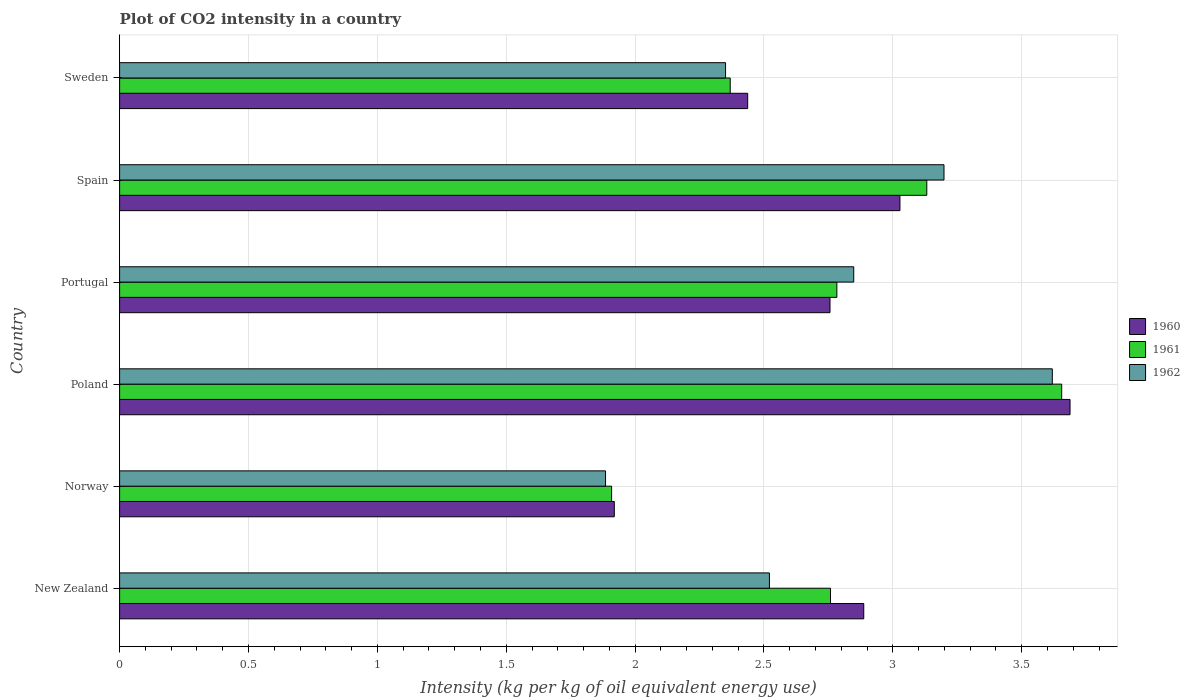How many different coloured bars are there?
Offer a terse response. 3. How many groups of bars are there?
Keep it short and to the point. 6. Are the number of bars per tick equal to the number of legend labels?
Keep it short and to the point. Yes. Are the number of bars on each tick of the Y-axis equal?
Provide a short and direct response. Yes. How many bars are there on the 3rd tick from the top?
Your response must be concise. 3. What is the label of the 1st group of bars from the top?
Give a very brief answer. Sweden. In how many cases, is the number of bars for a given country not equal to the number of legend labels?
Provide a succinct answer. 0. What is the CO2 intensity in in 1960 in Poland?
Ensure brevity in your answer.  3.69. Across all countries, what is the maximum CO2 intensity in in 1960?
Give a very brief answer. 3.69. Across all countries, what is the minimum CO2 intensity in in 1960?
Offer a terse response. 1.92. What is the total CO2 intensity in in 1960 in the graph?
Keep it short and to the point. 16.71. What is the difference between the CO2 intensity in in 1961 in Poland and that in Portugal?
Offer a terse response. 0.87. What is the difference between the CO2 intensity in in 1961 in Spain and the CO2 intensity in in 1960 in Sweden?
Offer a very short reply. 0.69. What is the average CO2 intensity in in 1962 per country?
Your answer should be compact. 2.74. What is the difference between the CO2 intensity in in 1960 and CO2 intensity in in 1962 in Spain?
Your response must be concise. -0.17. What is the ratio of the CO2 intensity in in 1960 in Norway to that in Spain?
Provide a succinct answer. 0.63. Is the CO2 intensity in in 1960 in Poland less than that in Portugal?
Ensure brevity in your answer.  No. What is the difference between the highest and the second highest CO2 intensity in in 1961?
Provide a succinct answer. 0.52. What is the difference between the highest and the lowest CO2 intensity in in 1962?
Your answer should be very brief. 1.73. What does the 2nd bar from the bottom in Portugal represents?
Give a very brief answer. 1961. Is it the case that in every country, the sum of the CO2 intensity in in 1960 and CO2 intensity in in 1961 is greater than the CO2 intensity in in 1962?
Ensure brevity in your answer.  Yes. How many bars are there?
Give a very brief answer. 18. Are all the bars in the graph horizontal?
Ensure brevity in your answer.  Yes. Are the values on the major ticks of X-axis written in scientific E-notation?
Provide a succinct answer. No. Does the graph contain any zero values?
Make the answer very short. No. Does the graph contain grids?
Offer a terse response. Yes. How many legend labels are there?
Offer a very short reply. 3. What is the title of the graph?
Your answer should be very brief. Plot of CO2 intensity in a country. Does "1996" appear as one of the legend labels in the graph?
Give a very brief answer. No. What is the label or title of the X-axis?
Ensure brevity in your answer.  Intensity (kg per kg of oil equivalent energy use). What is the label or title of the Y-axis?
Keep it short and to the point. Country. What is the Intensity (kg per kg of oil equivalent energy use) of 1960 in New Zealand?
Provide a short and direct response. 2.89. What is the Intensity (kg per kg of oil equivalent energy use) in 1961 in New Zealand?
Give a very brief answer. 2.76. What is the Intensity (kg per kg of oil equivalent energy use) in 1962 in New Zealand?
Give a very brief answer. 2.52. What is the Intensity (kg per kg of oil equivalent energy use) of 1960 in Norway?
Provide a succinct answer. 1.92. What is the Intensity (kg per kg of oil equivalent energy use) of 1961 in Norway?
Your answer should be very brief. 1.91. What is the Intensity (kg per kg of oil equivalent energy use) of 1962 in Norway?
Your answer should be very brief. 1.89. What is the Intensity (kg per kg of oil equivalent energy use) of 1960 in Poland?
Provide a succinct answer. 3.69. What is the Intensity (kg per kg of oil equivalent energy use) in 1961 in Poland?
Offer a very short reply. 3.66. What is the Intensity (kg per kg of oil equivalent energy use) of 1962 in Poland?
Your answer should be very brief. 3.62. What is the Intensity (kg per kg of oil equivalent energy use) of 1960 in Portugal?
Make the answer very short. 2.76. What is the Intensity (kg per kg of oil equivalent energy use) of 1961 in Portugal?
Give a very brief answer. 2.78. What is the Intensity (kg per kg of oil equivalent energy use) in 1962 in Portugal?
Offer a terse response. 2.85. What is the Intensity (kg per kg of oil equivalent energy use) of 1960 in Spain?
Make the answer very short. 3.03. What is the Intensity (kg per kg of oil equivalent energy use) in 1961 in Spain?
Ensure brevity in your answer.  3.13. What is the Intensity (kg per kg of oil equivalent energy use) of 1962 in Spain?
Provide a short and direct response. 3.2. What is the Intensity (kg per kg of oil equivalent energy use) in 1960 in Sweden?
Provide a short and direct response. 2.44. What is the Intensity (kg per kg of oil equivalent energy use) in 1961 in Sweden?
Your answer should be compact. 2.37. What is the Intensity (kg per kg of oil equivalent energy use) of 1962 in Sweden?
Your answer should be compact. 2.35. Across all countries, what is the maximum Intensity (kg per kg of oil equivalent energy use) in 1960?
Your response must be concise. 3.69. Across all countries, what is the maximum Intensity (kg per kg of oil equivalent energy use) of 1961?
Ensure brevity in your answer.  3.66. Across all countries, what is the maximum Intensity (kg per kg of oil equivalent energy use) in 1962?
Your answer should be compact. 3.62. Across all countries, what is the minimum Intensity (kg per kg of oil equivalent energy use) in 1960?
Your answer should be compact. 1.92. Across all countries, what is the minimum Intensity (kg per kg of oil equivalent energy use) of 1961?
Offer a very short reply. 1.91. Across all countries, what is the minimum Intensity (kg per kg of oil equivalent energy use) in 1962?
Make the answer very short. 1.89. What is the total Intensity (kg per kg of oil equivalent energy use) in 1960 in the graph?
Offer a terse response. 16.71. What is the total Intensity (kg per kg of oil equivalent energy use) in 1961 in the graph?
Ensure brevity in your answer.  16.61. What is the total Intensity (kg per kg of oil equivalent energy use) in 1962 in the graph?
Give a very brief answer. 16.42. What is the difference between the Intensity (kg per kg of oil equivalent energy use) in 1960 in New Zealand and that in Norway?
Make the answer very short. 0.97. What is the difference between the Intensity (kg per kg of oil equivalent energy use) in 1961 in New Zealand and that in Norway?
Offer a terse response. 0.85. What is the difference between the Intensity (kg per kg of oil equivalent energy use) of 1962 in New Zealand and that in Norway?
Give a very brief answer. 0.64. What is the difference between the Intensity (kg per kg of oil equivalent energy use) in 1960 in New Zealand and that in Poland?
Keep it short and to the point. -0.8. What is the difference between the Intensity (kg per kg of oil equivalent energy use) in 1961 in New Zealand and that in Poland?
Your answer should be very brief. -0.9. What is the difference between the Intensity (kg per kg of oil equivalent energy use) of 1962 in New Zealand and that in Poland?
Offer a terse response. -1.1. What is the difference between the Intensity (kg per kg of oil equivalent energy use) in 1960 in New Zealand and that in Portugal?
Provide a short and direct response. 0.13. What is the difference between the Intensity (kg per kg of oil equivalent energy use) in 1961 in New Zealand and that in Portugal?
Make the answer very short. -0.02. What is the difference between the Intensity (kg per kg of oil equivalent energy use) in 1962 in New Zealand and that in Portugal?
Your answer should be very brief. -0.33. What is the difference between the Intensity (kg per kg of oil equivalent energy use) of 1960 in New Zealand and that in Spain?
Your answer should be compact. -0.14. What is the difference between the Intensity (kg per kg of oil equivalent energy use) in 1961 in New Zealand and that in Spain?
Offer a very short reply. -0.37. What is the difference between the Intensity (kg per kg of oil equivalent energy use) in 1962 in New Zealand and that in Spain?
Your answer should be compact. -0.68. What is the difference between the Intensity (kg per kg of oil equivalent energy use) of 1960 in New Zealand and that in Sweden?
Make the answer very short. 0.45. What is the difference between the Intensity (kg per kg of oil equivalent energy use) of 1961 in New Zealand and that in Sweden?
Your answer should be compact. 0.39. What is the difference between the Intensity (kg per kg of oil equivalent energy use) of 1962 in New Zealand and that in Sweden?
Your answer should be compact. 0.17. What is the difference between the Intensity (kg per kg of oil equivalent energy use) of 1960 in Norway and that in Poland?
Offer a terse response. -1.77. What is the difference between the Intensity (kg per kg of oil equivalent energy use) of 1961 in Norway and that in Poland?
Your answer should be compact. -1.75. What is the difference between the Intensity (kg per kg of oil equivalent energy use) in 1962 in Norway and that in Poland?
Offer a terse response. -1.73. What is the difference between the Intensity (kg per kg of oil equivalent energy use) of 1960 in Norway and that in Portugal?
Your answer should be compact. -0.84. What is the difference between the Intensity (kg per kg of oil equivalent energy use) in 1961 in Norway and that in Portugal?
Offer a very short reply. -0.87. What is the difference between the Intensity (kg per kg of oil equivalent energy use) in 1962 in Norway and that in Portugal?
Your answer should be very brief. -0.96. What is the difference between the Intensity (kg per kg of oil equivalent energy use) of 1960 in Norway and that in Spain?
Provide a short and direct response. -1.11. What is the difference between the Intensity (kg per kg of oil equivalent energy use) of 1961 in Norway and that in Spain?
Your response must be concise. -1.22. What is the difference between the Intensity (kg per kg of oil equivalent energy use) of 1962 in Norway and that in Spain?
Ensure brevity in your answer.  -1.31. What is the difference between the Intensity (kg per kg of oil equivalent energy use) of 1960 in Norway and that in Sweden?
Your answer should be compact. -0.52. What is the difference between the Intensity (kg per kg of oil equivalent energy use) in 1961 in Norway and that in Sweden?
Provide a succinct answer. -0.46. What is the difference between the Intensity (kg per kg of oil equivalent energy use) in 1962 in Norway and that in Sweden?
Your answer should be very brief. -0.47. What is the difference between the Intensity (kg per kg of oil equivalent energy use) in 1960 in Poland and that in Portugal?
Offer a terse response. 0.93. What is the difference between the Intensity (kg per kg of oil equivalent energy use) in 1961 in Poland and that in Portugal?
Provide a succinct answer. 0.87. What is the difference between the Intensity (kg per kg of oil equivalent energy use) of 1962 in Poland and that in Portugal?
Give a very brief answer. 0.77. What is the difference between the Intensity (kg per kg of oil equivalent energy use) in 1960 in Poland and that in Spain?
Your answer should be compact. 0.66. What is the difference between the Intensity (kg per kg of oil equivalent energy use) of 1961 in Poland and that in Spain?
Keep it short and to the point. 0.52. What is the difference between the Intensity (kg per kg of oil equivalent energy use) of 1962 in Poland and that in Spain?
Offer a very short reply. 0.42. What is the difference between the Intensity (kg per kg of oil equivalent energy use) of 1960 in Poland and that in Sweden?
Offer a very short reply. 1.25. What is the difference between the Intensity (kg per kg of oil equivalent energy use) in 1961 in Poland and that in Sweden?
Provide a short and direct response. 1.29. What is the difference between the Intensity (kg per kg of oil equivalent energy use) in 1962 in Poland and that in Sweden?
Your response must be concise. 1.27. What is the difference between the Intensity (kg per kg of oil equivalent energy use) of 1960 in Portugal and that in Spain?
Ensure brevity in your answer.  -0.27. What is the difference between the Intensity (kg per kg of oil equivalent energy use) in 1961 in Portugal and that in Spain?
Your answer should be compact. -0.35. What is the difference between the Intensity (kg per kg of oil equivalent energy use) in 1962 in Portugal and that in Spain?
Offer a terse response. -0.35. What is the difference between the Intensity (kg per kg of oil equivalent energy use) of 1960 in Portugal and that in Sweden?
Offer a very short reply. 0.32. What is the difference between the Intensity (kg per kg of oil equivalent energy use) of 1961 in Portugal and that in Sweden?
Make the answer very short. 0.41. What is the difference between the Intensity (kg per kg of oil equivalent energy use) of 1962 in Portugal and that in Sweden?
Provide a succinct answer. 0.5. What is the difference between the Intensity (kg per kg of oil equivalent energy use) in 1960 in Spain and that in Sweden?
Provide a short and direct response. 0.59. What is the difference between the Intensity (kg per kg of oil equivalent energy use) in 1961 in Spain and that in Sweden?
Your answer should be very brief. 0.76. What is the difference between the Intensity (kg per kg of oil equivalent energy use) of 1962 in Spain and that in Sweden?
Give a very brief answer. 0.85. What is the difference between the Intensity (kg per kg of oil equivalent energy use) in 1960 in New Zealand and the Intensity (kg per kg of oil equivalent energy use) in 1961 in Norway?
Give a very brief answer. 0.98. What is the difference between the Intensity (kg per kg of oil equivalent energy use) in 1961 in New Zealand and the Intensity (kg per kg of oil equivalent energy use) in 1962 in Norway?
Your answer should be compact. 0.87. What is the difference between the Intensity (kg per kg of oil equivalent energy use) of 1960 in New Zealand and the Intensity (kg per kg of oil equivalent energy use) of 1961 in Poland?
Your answer should be very brief. -0.77. What is the difference between the Intensity (kg per kg of oil equivalent energy use) of 1960 in New Zealand and the Intensity (kg per kg of oil equivalent energy use) of 1962 in Poland?
Offer a terse response. -0.73. What is the difference between the Intensity (kg per kg of oil equivalent energy use) in 1961 in New Zealand and the Intensity (kg per kg of oil equivalent energy use) in 1962 in Poland?
Your answer should be compact. -0.86. What is the difference between the Intensity (kg per kg of oil equivalent energy use) of 1960 in New Zealand and the Intensity (kg per kg of oil equivalent energy use) of 1961 in Portugal?
Give a very brief answer. 0.1. What is the difference between the Intensity (kg per kg of oil equivalent energy use) in 1960 in New Zealand and the Intensity (kg per kg of oil equivalent energy use) in 1962 in Portugal?
Give a very brief answer. 0.04. What is the difference between the Intensity (kg per kg of oil equivalent energy use) of 1961 in New Zealand and the Intensity (kg per kg of oil equivalent energy use) of 1962 in Portugal?
Offer a terse response. -0.09. What is the difference between the Intensity (kg per kg of oil equivalent energy use) of 1960 in New Zealand and the Intensity (kg per kg of oil equivalent energy use) of 1961 in Spain?
Keep it short and to the point. -0.24. What is the difference between the Intensity (kg per kg of oil equivalent energy use) of 1960 in New Zealand and the Intensity (kg per kg of oil equivalent energy use) of 1962 in Spain?
Ensure brevity in your answer.  -0.31. What is the difference between the Intensity (kg per kg of oil equivalent energy use) of 1961 in New Zealand and the Intensity (kg per kg of oil equivalent energy use) of 1962 in Spain?
Provide a succinct answer. -0.44. What is the difference between the Intensity (kg per kg of oil equivalent energy use) of 1960 in New Zealand and the Intensity (kg per kg of oil equivalent energy use) of 1961 in Sweden?
Your answer should be very brief. 0.52. What is the difference between the Intensity (kg per kg of oil equivalent energy use) of 1960 in New Zealand and the Intensity (kg per kg of oil equivalent energy use) of 1962 in Sweden?
Keep it short and to the point. 0.54. What is the difference between the Intensity (kg per kg of oil equivalent energy use) of 1961 in New Zealand and the Intensity (kg per kg of oil equivalent energy use) of 1962 in Sweden?
Keep it short and to the point. 0.41. What is the difference between the Intensity (kg per kg of oil equivalent energy use) in 1960 in Norway and the Intensity (kg per kg of oil equivalent energy use) in 1961 in Poland?
Provide a short and direct response. -1.74. What is the difference between the Intensity (kg per kg of oil equivalent energy use) in 1960 in Norway and the Intensity (kg per kg of oil equivalent energy use) in 1962 in Poland?
Your answer should be very brief. -1.7. What is the difference between the Intensity (kg per kg of oil equivalent energy use) in 1961 in Norway and the Intensity (kg per kg of oil equivalent energy use) in 1962 in Poland?
Offer a terse response. -1.71. What is the difference between the Intensity (kg per kg of oil equivalent energy use) of 1960 in Norway and the Intensity (kg per kg of oil equivalent energy use) of 1961 in Portugal?
Keep it short and to the point. -0.86. What is the difference between the Intensity (kg per kg of oil equivalent energy use) in 1960 in Norway and the Intensity (kg per kg of oil equivalent energy use) in 1962 in Portugal?
Your answer should be compact. -0.93. What is the difference between the Intensity (kg per kg of oil equivalent energy use) in 1961 in Norway and the Intensity (kg per kg of oil equivalent energy use) in 1962 in Portugal?
Provide a short and direct response. -0.94. What is the difference between the Intensity (kg per kg of oil equivalent energy use) of 1960 in Norway and the Intensity (kg per kg of oil equivalent energy use) of 1961 in Spain?
Provide a succinct answer. -1.21. What is the difference between the Intensity (kg per kg of oil equivalent energy use) of 1960 in Norway and the Intensity (kg per kg of oil equivalent energy use) of 1962 in Spain?
Your answer should be very brief. -1.28. What is the difference between the Intensity (kg per kg of oil equivalent energy use) in 1961 in Norway and the Intensity (kg per kg of oil equivalent energy use) in 1962 in Spain?
Offer a terse response. -1.29. What is the difference between the Intensity (kg per kg of oil equivalent energy use) in 1960 in Norway and the Intensity (kg per kg of oil equivalent energy use) in 1961 in Sweden?
Your answer should be very brief. -0.45. What is the difference between the Intensity (kg per kg of oil equivalent energy use) of 1960 in Norway and the Intensity (kg per kg of oil equivalent energy use) of 1962 in Sweden?
Make the answer very short. -0.43. What is the difference between the Intensity (kg per kg of oil equivalent energy use) in 1961 in Norway and the Intensity (kg per kg of oil equivalent energy use) in 1962 in Sweden?
Ensure brevity in your answer.  -0.44. What is the difference between the Intensity (kg per kg of oil equivalent energy use) of 1960 in Poland and the Intensity (kg per kg of oil equivalent energy use) of 1961 in Portugal?
Your answer should be compact. 0.9. What is the difference between the Intensity (kg per kg of oil equivalent energy use) of 1960 in Poland and the Intensity (kg per kg of oil equivalent energy use) of 1962 in Portugal?
Ensure brevity in your answer.  0.84. What is the difference between the Intensity (kg per kg of oil equivalent energy use) of 1961 in Poland and the Intensity (kg per kg of oil equivalent energy use) of 1962 in Portugal?
Provide a short and direct response. 0.81. What is the difference between the Intensity (kg per kg of oil equivalent energy use) in 1960 in Poland and the Intensity (kg per kg of oil equivalent energy use) in 1961 in Spain?
Your answer should be compact. 0.56. What is the difference between the Intensity (kg per kg of oil equivalent energy use) in 1960 in Poland and the Intensity (kg per kg of oil equivalent energy use) in 1962 in Spain?
Your response must be concise. 0.49. What is the difference between the Intensity (kg per kg of oil equivalent energy use) in 1961 in Poland and the Intensity (kg per kg of oil equivalent energy use) in 1962 in Spain?
Offer a terse response. 0.46. What is the difference between the Intensity (kg per kg of oil equivalent energy use) of 1960 in Poland and the Intensity (kg per kg of oil equivalent energy use) of 1961 in Sweden?
Give a very brief answer. 1.32. What is the difference between the Intensity (kg per kg of oil equivalent energy use) of 1960 in Poland and the Intensity (kg per kg of oil equivalent energy use) of 1962 in Sweden?
Give a very brief answer. 1.34. What is the difference between the Intensity (kg per kg of oil equivalent energy use) in 1961 in Poland and the Intensity (kg per kg of oil equivalent energy use) in 1962 in Sweden?
Ensure brevity in your answer.  1.3. What is the difference between the Intensity (kg per kg of oil equivalent energy use) of 1960 in Portugal and the Intensity (kg per kg of oil equivalent energy use) of 1961 in Spain?
Ensure brevity in your answer.  -0.38. What is the difference between the Intensity (kg per kg of oil equivalent energy use) in 1960 in Portugal and the Intensity (kg per kg of oil equivalent energy use) in 1962 in Spain?
Keep it short and to the point. -0.44. What is the difference between the Intensity (kg per kg of oil equivalent energy use) of 1961 in Portugal and the Intensity (kg per kg of oil equivalent energy use) of 1962 in Spain?
Make the answer very short. -0.42. What is the difference between the Intensity (kg per kg of oil equivalent energy use) of 1960 in Portugal and the Intensity (kg per kg of oil equivalent energy use) of 1961 in Sweden?
Provide a succinct answer. 0.39. What is the difference between the Intensity (kg per kg of oil equivalent energy use) of 1960 in Portugal and the Intensity (kg per kg of oil equivalent energy use) of 1962 in Sweden?
Your answer should be very brief. 0.41. What is the difference between the Intensity (kg per kg of oil equivalent energy use) of 1961 in Portugal and the Intensity (kg per kg of oil equivalent energy use) of 1962 in Sweden?
Provide a succinct answer. 0.43. What is the difference between the Intensity (kg per kg of oil equivalent energy use) of 1960 in Spain and the Intensity (kg per kg of oil equivalent energy use) of 1961 in Sweden?
Make the answer very short. 0.66. What is the difference between the Intensity (kg per kg of oil equivalent energy use) in 1960 in Spain and the Intensity (kg per kg of oil equivalent energy use) in 1962 in Sweden?
Your response must be concise. 0.68. What is the difference between the Intensity (kg per kg of oil equivalent energy use) in 1961 in Spain and the Intensity (kg per kg of oil equivalent energy use) in 1962 in Sweden?
Keep it short and to the point. 0.78. What is the average Intensity (kg per kg of oil equivalent energy use) of 1960 per country?
Your answer should be compact. 2.79. What is the average Intensity (kg per kg of oil equivalent energy use) in 1961 per country?
Keep it short and to the point. 2.77. What is the average Intensity (kg per kg of oil equivalent energy use) in 1962 per country?
Your answer should be compact. 2.74. What is the difference between the Intensity (kg per kg of oil equivalent energy use) in 1960 and Intensity (kg per kg of oil equivalent energy use) in 1961 in New Zealand?
Ensure brevity in your answer.  0.13. What is the difference between the Intensity (kg per kg of oil equivalent energy use) in 1960 and Intensity (kg per kg of oil equivalent energy use) in 1962 in New Zealand?
Make the answer very short. 0.37. What is the difference between the Intensity (kg per kg of oil equivalent energy use) of 1961 and Intensity (kg per kg of oil equivalent energy use) of 1962 in New Zealand?
Your response must be concise. 0.24. What is the difference between the Intensity (kg per kg of oil equivalent energy use) in 1960 and Intensity (kg per kg of oil equivalent energy use) in 1961 in Norway?
Make the answer very short. 0.01. What is the difference between the Intensity (kg per kg of oil equivalent energy use) in 1960 and Intensity (kg per kg of oil equivalent energy use) in 1962 in Norway?
Your response must be concise. 0.03. What is the difference between the Intensity (kg per kg of oil equivalent energy use) of 1961 and Intensity (kg per kg of oil equivalent energy use) of 1962 in Norway?
Your response must be concise. 0.02. What is the difference between the Intensity (kg per kg of oil equivalent energy use) in 1960 and Intensity (kg per kg of oil equivalent energy use) in 1961 in Poland?
Give a very brief answer. 0.03. What is the difference between the Intensity (kg per kg of oil equivalent energy use) in 1960 and Intensity (kg per kg of oil equivalent energy use) in 1962 in Poland?
Ensure brevity in your answer.  0.07. What is the difference between the Intensity (kg per kg of oil equivalent energy use) of 1961 and Intensity (kg per kg of oil equivalent energy use) of 1962 in Poland?
Offer a very short reply. 0.04. What is the difference between the Intensity (kg per kg of oil equivalent energy use) in 1960 and Intensity (kg per kg of oil equivalent energy use) in 1961 in Portugal?
Your response must be concise. -0.03. What is the difference between the Intensity (kg per kg of oil equivalent energy use) in 1960 and Intensity (kg per kg of oil equivalent energy use) in 1962 in Portugal?
Make the answer very short. -0.09. What is the difference between the Intensity (kg per kg of oil equivalent energy use) in 1961 and Intensity (kg per kg of oil equivalent energy use) in 1962 in Portugal?
Your response must be concise. -0.07. What is the difference between the Intensity (kg per kg of oil equivalent energy use) in 1960 and Intensity (kg per kg of oil equivalent energy use) in 1961 in Spain?
Ensure brevity in your answer.  -0.1. What is the difference between the Intensity (kg per kg of oil equivalent energy use) in 1960 and Intensity (kg per kg of oil equivalent energy use) in 1962 in Spain?
Your response must be concise. -0.17. What is the difference between the Intensity (kg per kg of oil equivalent energy use) of 1961 and Intensity (kg per kg of oil equivalent energy use) of 1962 in Spain?
Provide a short and direct response. -0.07. What is the difference between the Intensity (kg per kg of oil equivalent energy use) in 1960 and Intensity (kg per kg of oil equivalent energy use) in 1961 in Sweden?
Provide a short and direct response. 0.07. What is the difference between the Intensity (kg per kg of oil equivalent energy use) in 1960 and Intensity (kg per kg of oil equivalent energy use) in 1962 in Sweden?
Offer a terse response. 0.09. What is the difference between the Intensity (kg per kg of oil equivalent energy use) of 1961 and Intensity (kg per kg of oil equivalent energy use) of 1962 in Sweden?
Ensure brevity in your answer.  0.02. What is the ratio of the Intensity (kg per kg of oil equivalent energy use) in 1960 in New Zealand to that in Norway?
Your answer should be very brief. 1.5. What is the ratio of the Intensity (kg per kg of oil equivalent energy use) in 1961 in New Zealand to that in Norway?
Your response must be concise. 1.44. What is the ratio of the Intensity (kg per kg of oil equivalent energy use) in 1962 in New Zealand to that in Norway?
Give a very brief answer. 1.34. What is the ratio of the Intensity (kg per kg of oil equivalent energy use) of 1960 in New Zealand to that in Poland?
Your answer should be compact. 0.78. What is the ratio of the Intensity (kg per kg of oil equivalent energy use) in 1961 in New Zealand to that in Poland?
Make the answer very short. 0.75. What is the ratio of the Intensity (kg per kg of oil equivalent energy use) of 1962 in New Zealand to that in Poland?
Provide a succinct answer. 0.7. What is the ratio of the Intensity (kg per kg of oil equivalent energy use) in 1960 in New Zealand to that in Portugal?
Give a very brief answer. 1.05. What is the ratio of the Intensity (kg per kg of oil equivalent energy use) in 1962 in New Zealand to that in Portugal?
Keep it short and to the point. 0.89. What is the ratio of the Intensity (kg per kg of oil equivalent energy use) of 1960 in New Zealand to that in Spain?
Your response must be concise. 0.95. What is the ratio of the Intensity (kg per kg of oil equivalent energy use) in 1961 in New Zealand to that in Spain?
Your answer should be very brief. 0.88. What is the ratio of the Intensity (kg per kg of oil equivalent energy use) of 1962 in New Zealand to that in Spain?
Give a very brief answer. 0.79. What is the ratio of the Intensity (kg per kg of oil equivalent energy use) in 1960 in New Zealand to that in Sweden?
Your answer should be compact. 1.18. What is the ratio of the Intensity (kg per kg of oil equivalent energy use) of 1961 in New Zealand to that in Sweden?
Keep it short and to the point. 1.16. What is the ratio of the Intensity (kg per kg of oil equivalent energy use) of 1962 in New Zealand to that in Sweden?
Keep it short and to the point. 1.07. What is the ratio of the Intensity (kg per kg of oil equivalent energy use) of 1960 in Norway to that in Poland?
Make the answer very short. 0.52. What is the ratio of the Intensity (kg per kg of oil equivalent energy use) of 1961 in Norway to that in Poland?
Your answer should be compact. 0.52. What is the ratio of the Intensity (kg per kg of oil equivalent energy use) of 1962 in Norway to that in Poland?
Provide a short and direct response. 0.52. What is the ratio of the Intensity (kg per kg of oil equivalent energy use) of 1960 in Norway to that in Portugal?
Ensure brevity in your answer.  0.7. What is the ratio of the Intensity (kg per kg of oil equivalent energy use) in 1961 in Norway to that in Portugal?
Provide a succinct answer. 0.69. What is the ratio of the Intensity (kg per kg of oil equivalent energy use) of 1962 in Norway to that in Portugal?
Offer a terse response. 0.66. What is the ratio of the Intensity (kg per kg of oil equivalent energy use) of 1960 in Norway to that in Spain?
Make the answer very short. 0.63. What is the ratio of the Intensity (kg per kg of oil equivalent energy use) of 1961 in Norway to that in Spain?
Offer a terse response. 0.61. What is the ratio of the Intensity (kg per kg of oil equivalent energy use) of 1962 in Norway to that in Spain?
Offer a terse response. 0.59. What is the ratio of the Intensity (kg per kg of oil equivalent energy use) of 1960 in Norway to that in Sweden?
Keep it short and to the point. 0.79. What is the ratio of the Intensity (kg per kg of oil equivalent energy use) of 1961 in Norway to that in Sweden?
Provide a short and direct response. 0.81. What is the ratio of the Intensity (kg per kg of oil equivalent energy use) of 1962 in Norway to that in Sweden?
Your answer should be very brief. 0.8. What is the ratio of the Intensity (kg per kg of oil equivalent energy use) in 1960 in Poland to that in Portugal?
Offer a very short reply. 1.34. What is the ratio of the Intensity (kg per kg of oil equivalent energy use) of 1961 in Poland to that in Portugal?
Offer a very short reply. 1.31. What is the ratio of the Intensity (kg per kg of oil equivalent energy use) of 1962 in Poland to that in Portugal?
Your response must be concise. 1.27. What is the ratio of the Intensity (kg per kg of oil equivalent energy use) of 1960 in Poland to that in Spain?
Provide a short and direct response. 1.22. What is the ratio of the Intensity (kg per kg of oil equivalent energy use) in 1961 in Poland to that in Spain?
Your response must be concise. 1.17. What is the ratio of the Intensity (kg per kg of oil equivalent energy use) in 1962 in Poland to that in Spain?
Your response must be concise. 1.13. What is the ratio of the Intensity (kg per kg of oil equivalent energy use) in 1960 in Poland to that in Sweden?
Your response must be concise. 1.51. What is the ratio of the Intensity (kg per kg of oil equivalent energy use) of 1961 in Poland to that in Sweden?
Your answer should be very brief. 1.54. What is the ratio of the Intensity (kg per kg of oil equivalent energy use) of 1962 in Poland to that in Sweden?
Provide a short and direct response. 1.54. What is the ratio of the Intensity (kg per kg of oil equivalent energy use) in 1960 in Portugal to that in Spain?
Offer a terse response. 0.91. What is the ratio of the Intensity (kg per kg of oil equivalent energy use) of 1961 in Portugal to that in Spain?
Ensure brevity in your answer.  0.89. What is the ratio of the Intensity (kg per kg of oil equivalent energy use) in 1962 in Portugal to that in Spain?
Offer a terse response. 0.89. What is the ratio of the Intensity (kg per kg of oil equivalent energy use) of 1960 in Portugal to that in Sweden?
Your answer should be compact. 1.13. What is the ratio of the Intensity (kg per kg of oil equivalent energy use) of 1961 in Portugal to that in Sweden?
Your answer should be compact. 1.17. What is the ratio of the Intensity (kg per kg of oil equivalent energy use) of 1962 in Portugal to that in Sweden?
Ensure brevity in your answer.  1.21. What is the ratio of the Intensity (kg per kg of oil equivalent energy use) of 1960 in Spain to that in Sweden?
Provide a short and direct response. 1.24. What is the ratio of the Intensity (kg per kg of oil equivalent energy use) of 1961 in Spain to that in Sweden?
Provide a short and direct response. 1.32. What is the ratio of the Intensity (kg per kg of oil equivalent energy use) in 1962 in Spain to that in Sweden?
Provide a short and direct response. 1.36. What is the difference between the highest and the second highest Intensity (kg per kg of oil equivalent energy use) of 1960?
Your response must be concise. 0.66. What is the difference between the highest and the second highest Intensity (kg per kg of oil equivalent energy use) of 1961?
Your answer should be very brief. 0.52. What is the difference between the highest and the second highest Intensity (kg per kg of oil equivalent energy use) in 1962?
Offer a terse response. 0.42. What is the difference between the highest and the lowest Intensity (kg per kg of oil equivalent energy use) in 1960?
Make the answer very short. 1.77. What is the difference between the highest and the lowest Intensity (kg per kg of oil equivalent energy use) in 1961?
Give a very brief answer. 1.75. What is the difference between the highest and the lowest Intensity (kg per kg of oil equivalent energy use) of 1962?
Keep it short and to the point. 1.73. 